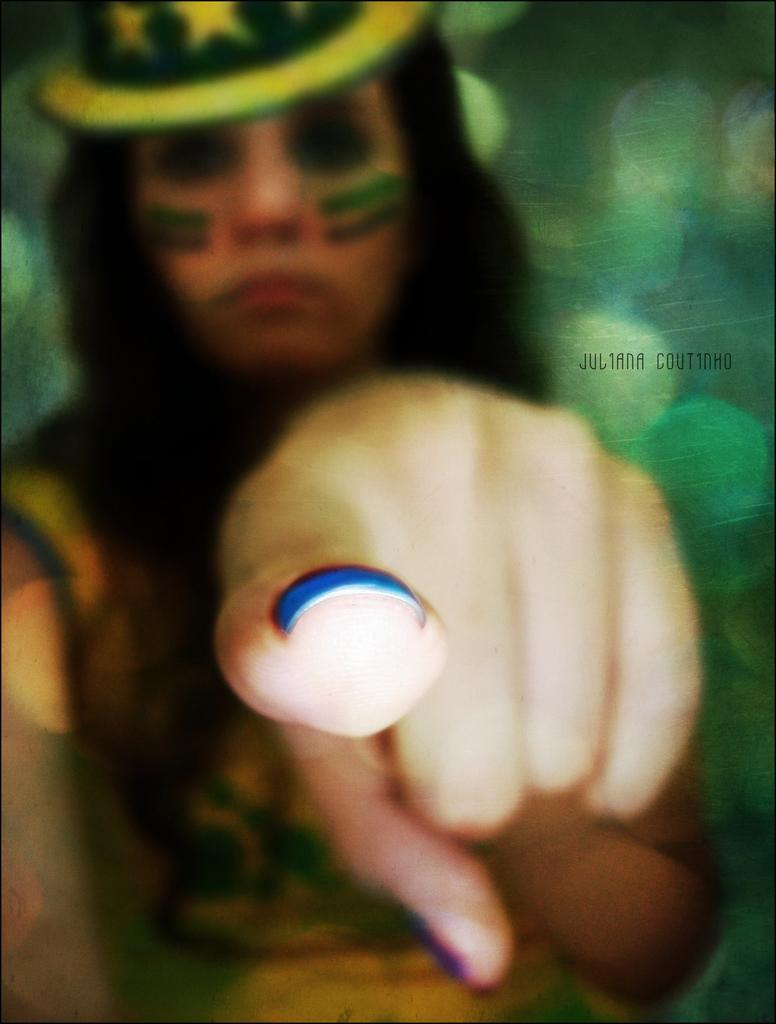What is the main subject of the image? The main subject of the image is a lady. What is the lady doing in the image? The lady is pointing her finger to the camera. How many ladybugs can be seen flying around the lady in the image? There are no ladybugs present in the image. What type of waves can be seen crashing on the shore in the image? There is no shore or waves present in the image. Where is the faucet located in the image? There is no faucet present in the image. 